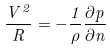Convert formula to latex. <formula><loc_0><loc_0><loc_500><loc_500>\frac { V ^ { 2 } } { R } = - \frac { 1 } { \rho } \frac { \partial p } { \partial n }</formula> 